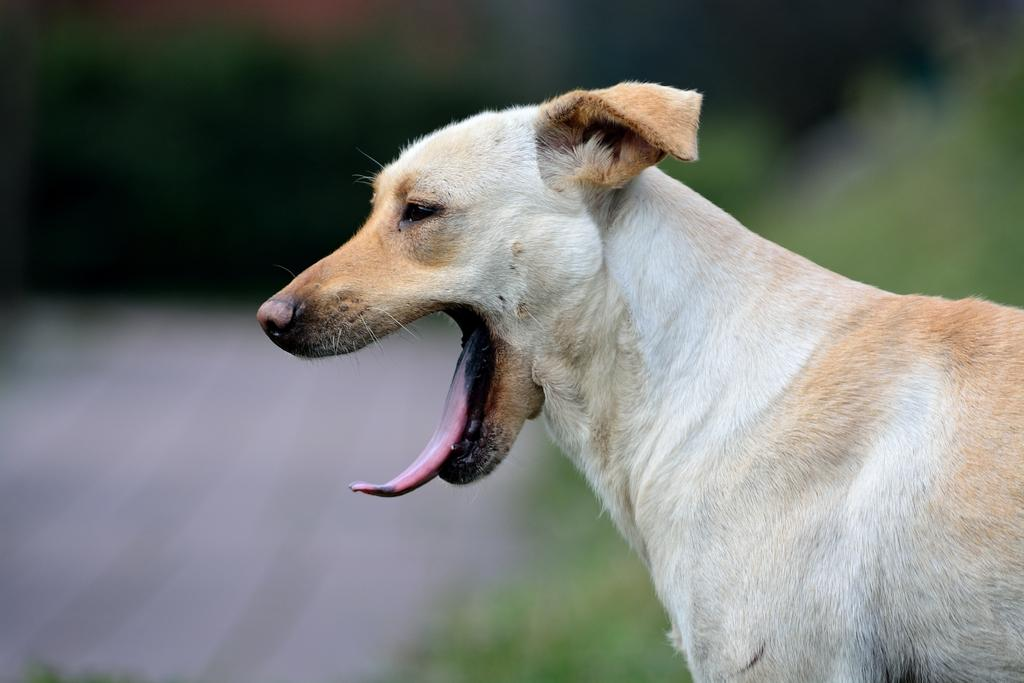What type of animal is in the image? There is a dog in the image. Can you describe the color of the dog? The dog is white and light brown in color. What can be observed about the background of the image? The background of the image is blurred. How many birds are sitting on the wool in the image? There are no birds or wool present in the image; it features a dog with a blurred background. 